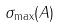<formula> <loc_0><loc_0><loc_500><loc_500>\sigma _ { \max } ( A )</formula> 